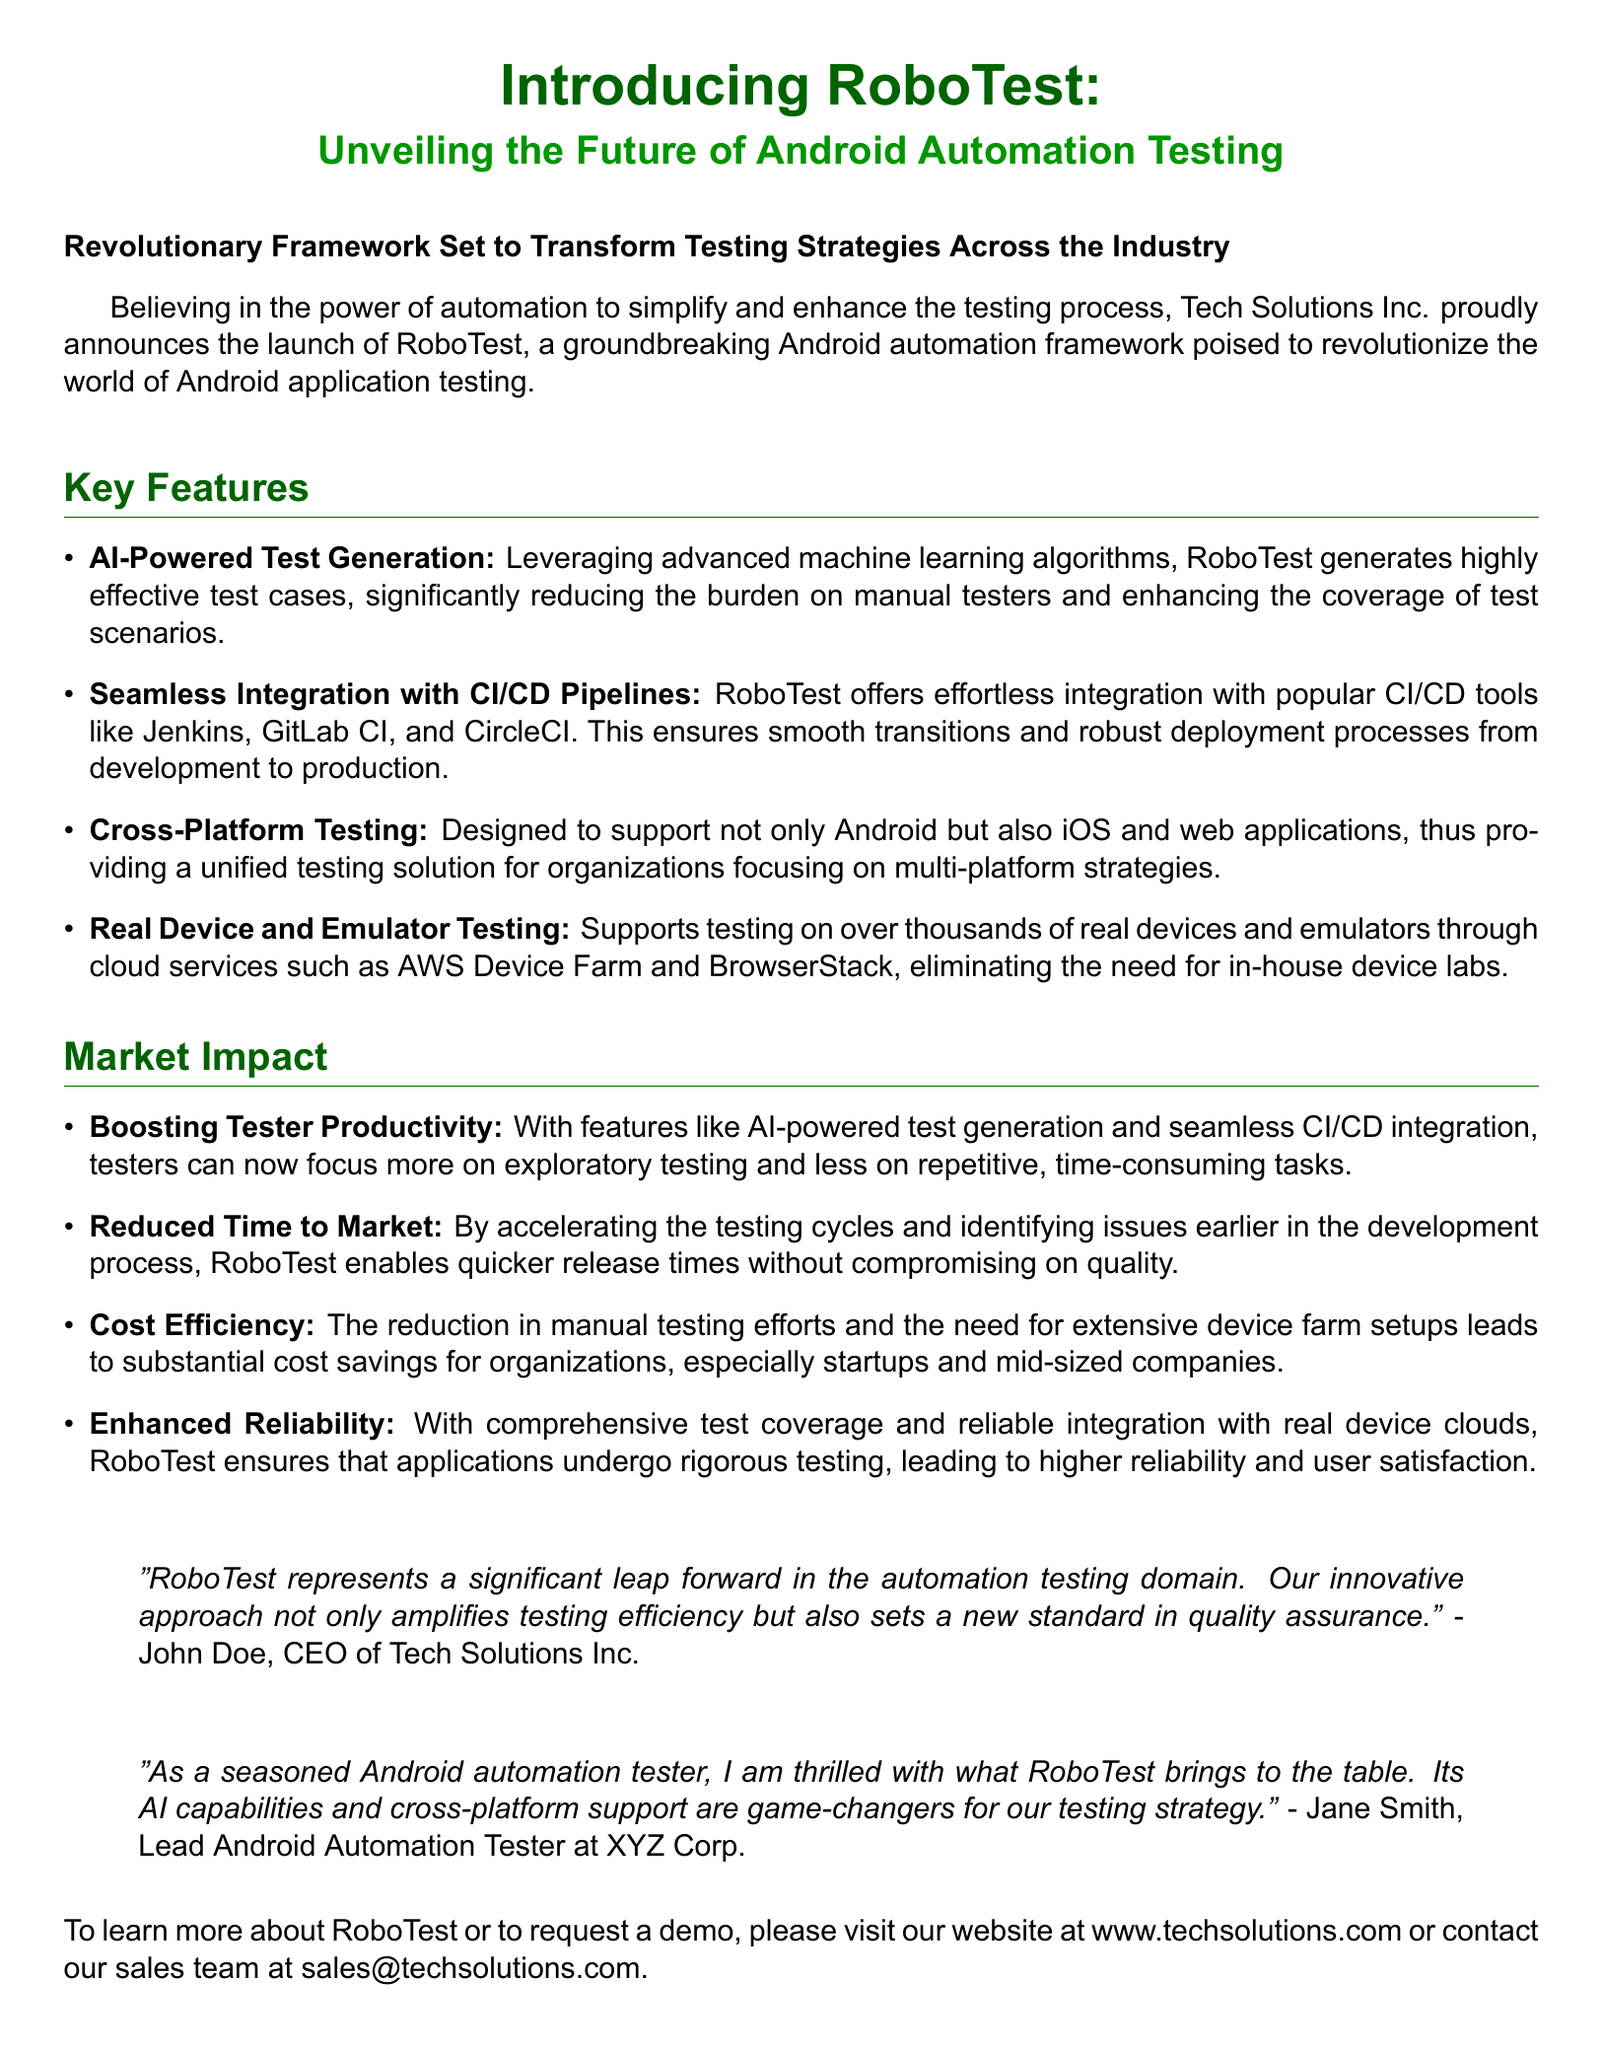What is the name of the new framework? The name of the new framework is mentioned at the beginning of the document.
Answer: RoboTest Who is the CEO of Tech Solutions Inc.? The CEO is quoted in the document, providing insight into the framework's significance.
Answer: John Doe What does RoboTest leverage for test generation? The document specifies the technology used for test generation in RoboTest.
Answer: AI-Powered Test Generation Which CI/CD tools can RoboTest integrate with? The document lists popular CI/CD tools that RoboTest can seamlessly integrate with.
Answer: Jenkins, GitLab CI, CircleCI What type of testing is supported besides Android? The document states the other platform types supported by RoboTest.
Answer: iOS and web applications How does RoboTest contribute to reducing time to market? The improvement in testing processes leads to quicker release times as described in the document.
Answer: By accelerating testing cycles What significant advantage does RoboTest provide for startups? The advantages of RoboTest for smaller organizations are highlighted in the market impact section.
Answer: Cost Efficiency Who expressed excitement about RoboTest from the tester's perspective? A quote from a lead automation tester in the document showcases their enthusiasm for RoboTest.
Answer: Jane Smith What does the quote from John Doe suggest about RoboTest's impact? The quote reflects on RoboTest's potential influence in the automation testing domain.
Answer: Significant leap forward 